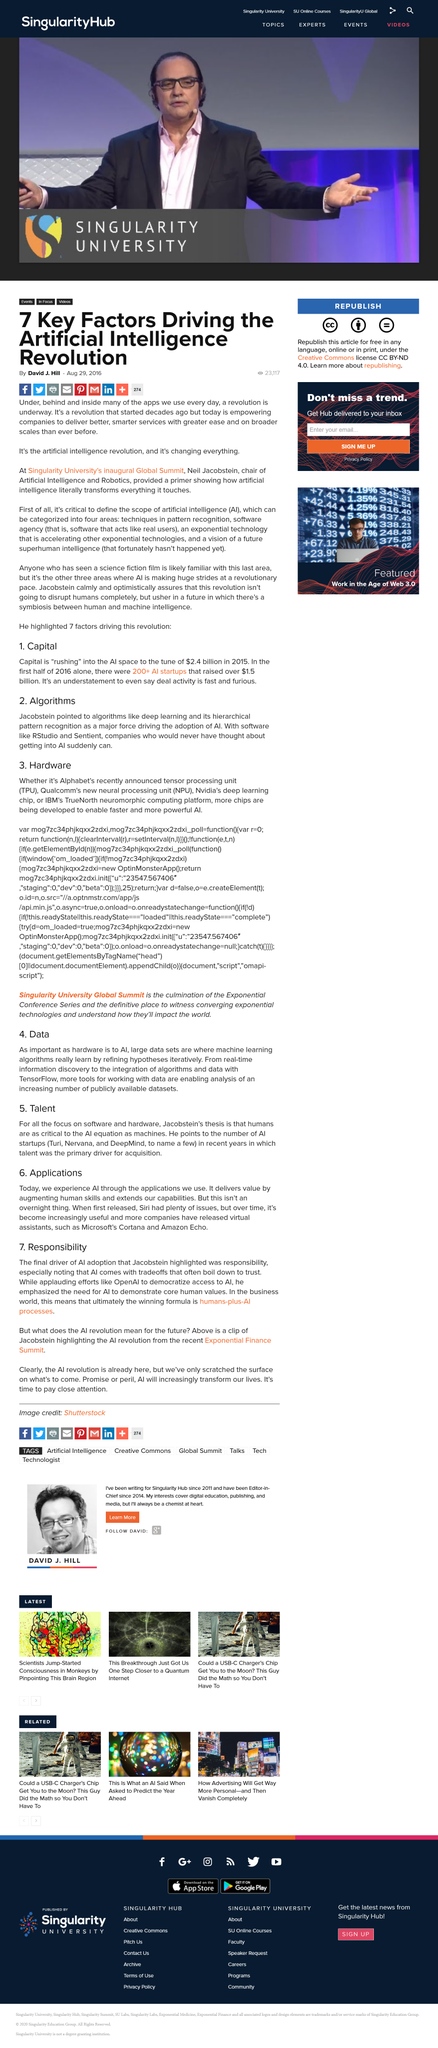Identify some key points in this picture. The Artificial Intelligence revolution is enabling companies to provide exceptional, shrewd services with unprecedented ease and on a more extensive scale than ever before. Neil Jacobstein is the chair of Artificial Intelligence and Robotics at Singularity University. Artificial Intelligence (AI) can be categorised into four areas: narrow or weak AI, weak AI, general or strong AI, and superintelligent AI. 